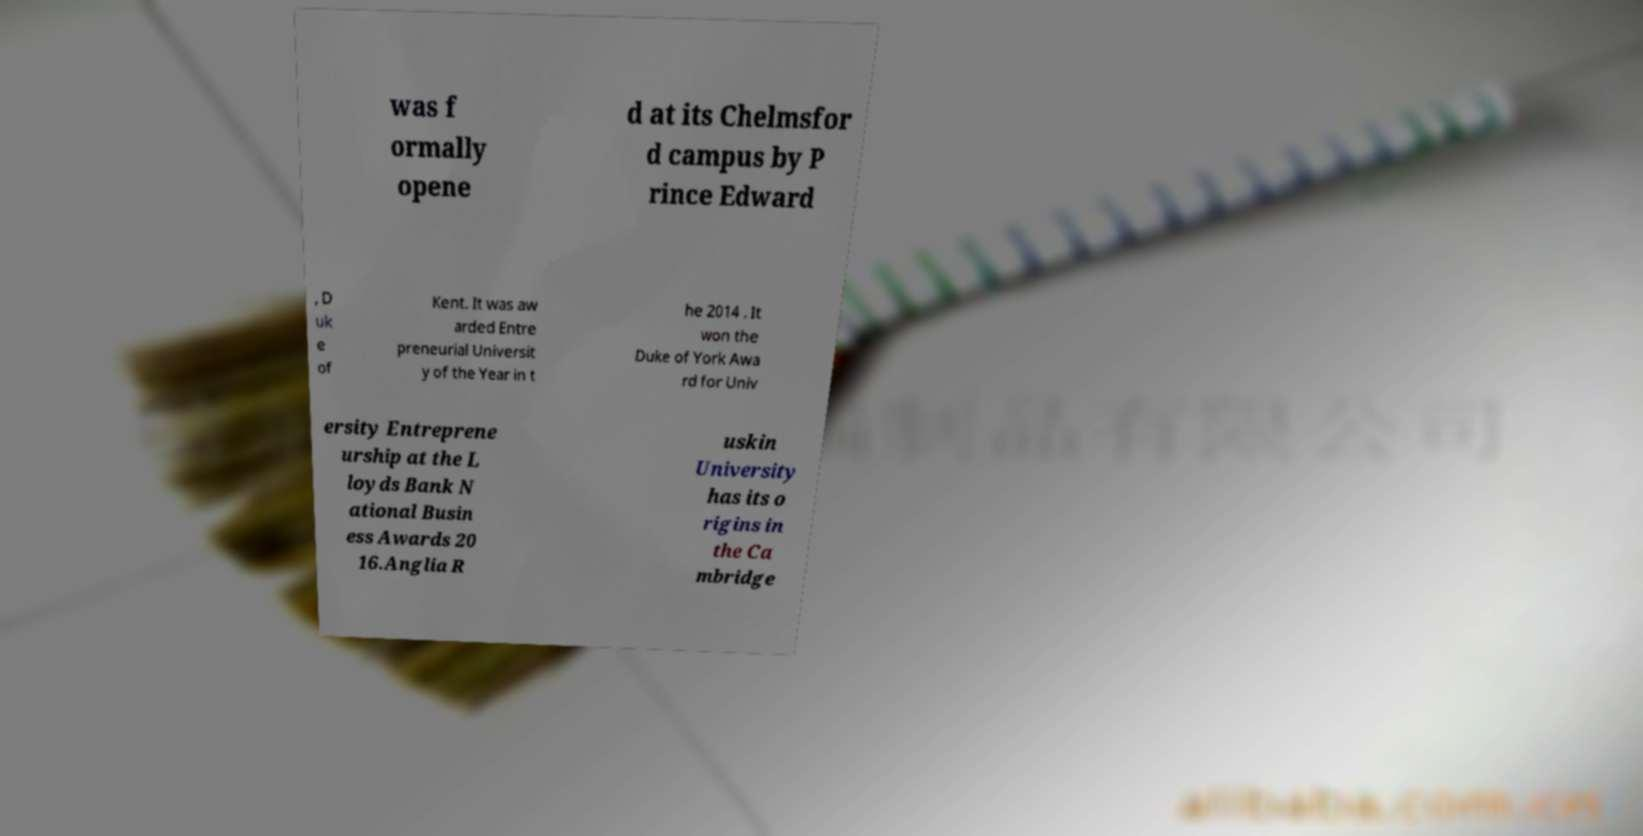I need the written content from this picture converted into text. Can you do that? was f ormally opene d at its Chelmsfor d campus by P rince Edward , D uk e of Kent. It was aw arded Entre preneurial Universit y of the Year in t he 2014 . It won the Duke of York Awa rd for Univ ersity Entreprene urship at the L loyds Bank N ational Busin ess Awards 20 16.Anglia R uskin University has its o rigins in the Ca mbridge 